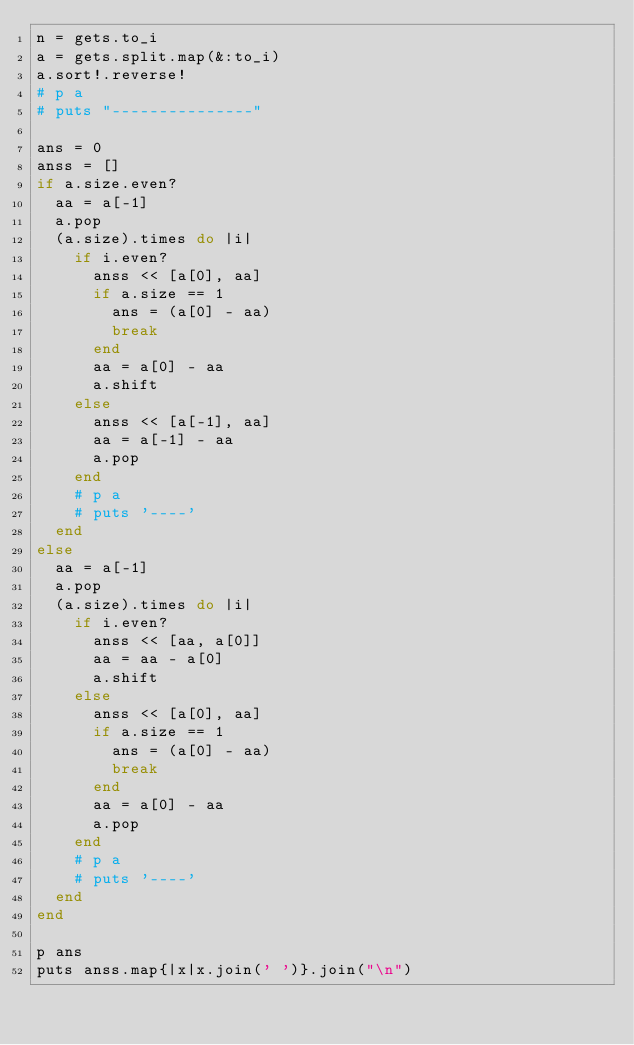Convert code to text. <code><loc_0><loc_0><loc_500><loc_500><_Ruby_>n = gets.to_i
a = gets.split.map(&:to_i)
a.sort!.reverse!
# p a
# puts "---------------"

ans = 0
anss = []
if a.size.even?
  aa = a[-1]
  a.pop
  (a.size).times do |i|
    if i.even?
      anss << [a[0], aa]
      if a.size == 1
        ans = (a[0] - aa)
        break
      end
      aa = a[0] - aa
      a.shift
    else
      anss << [a[-1], aa]
      aa = a[-1] - aa
      a.pop
    end
    # p a
    # puts '----'
  end
else
  aa = a[-1]
  a.pop
  (a.size).times do |i|
    if i.even?
      anss << [aa, a[0]]
      aa = aa - a[0]
      a.shift
    else
      anss << [a[0], aa]
      if a.size == 1
        ans = (a[0] - aa)
        break
      end
      aa = a[0] - aa
      a.pop
    end
    # p a
    # puts '----'
  end
end

p ans
puts anss.map{|x|x.join(' ')}.join("\n")
</code> 